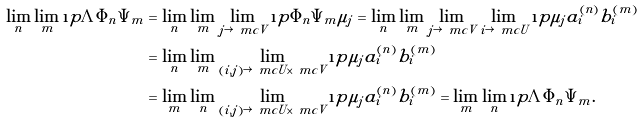<formula> <loc_0><loc_0><loc_500><loc_500>\lim _ { n } \lim _ { m } \i p { \Lambda } { \Phi _ { n } \Psi _ { m } } & = \lim _ { n } \lim _ { m } \lim _ { j \rightarrow \ m c V } \i p { \Phi _ { n } \Psi _ { m } } { \mu _ { j } } = \lim _ { n } \lim _ { m } \lim _ { j \rightarrow \ m c V } \lim _ { i \rightarrow \ m c U } \i p { \mu _ { j } } { a ^ { ( n ) } _ { i } b ^ { ( m ) } _ { i } } \\ & = \lim _ { n } \lim _ { m } \lim _ { ( i , j ) \rightarrow \ m c U \times \ m c V } \i p { \mu _ { j } } { a ^ { ( n ) } _ { i } b ^ { ( m ) } _ { i } } \\ & = \lim _ { m } \lim _ { n } \lim _ { ( i , j ) \rightarrow \ m c U \times \ m c V } \i p { \mu _ { j } } { a ^ { ( n ) } _ { i } b ^ { ( m ) } _ { i } } = \lim _ { m } \lim _ { n } \i p { \Lambda } { \Phi _ { n } \Psi _ { m } } .</formula> 